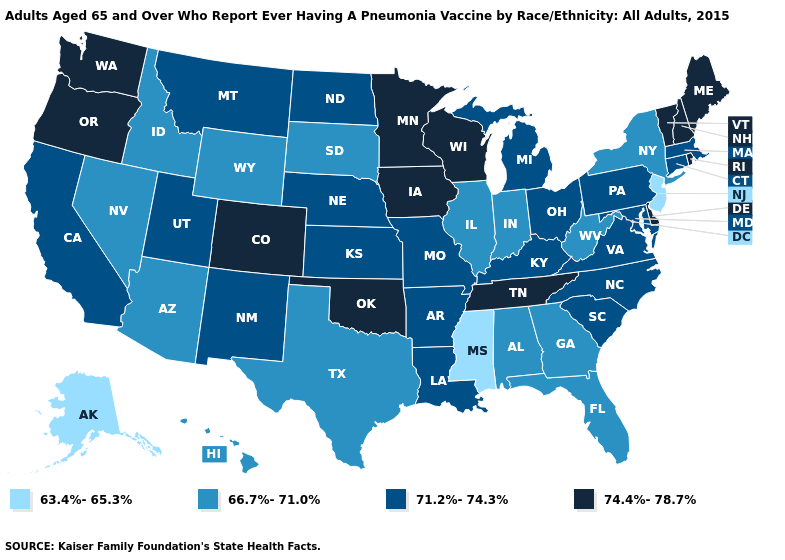Name the states that have a value in the range 63.4%-65.3%?
Keep it brief. Alaska, Mississippi, New Jersey. What is the lowest value in states that border Kentucky?
Answer briefly. 66.7%-71.0%. Name the states that have a value in the range 66.7%-71.0%?
Write a very short answer. Alabama, Arizona, Florida, Georgia, Hawaii, Idaho, Illinois, Indiana, Nevada, New York, South Dakota, Texas, West Virginia, Wyoming. Does Colorado have the same value as Washington?
Keep it brief. Yes. Name the states that have a value in the range 63.4%-65.3%?
Short answer required. Alaska, Mississippi, New Jersey. What is the value of Hawaii?
Give a very brief answer. 66.7%-71.0%. Does the first symbol in the legend represent the smallest category?
Answer briefly. Yes. Name the states that have a value in the range 66.7%-71.0%?
Write a very short answer. Alabama, Arizona, Florida, Georgia, Hawaii, Idaho, Illinois, Indiana, Nevada, New York, South Dakota, Texas, West Virginia, Wyoming. Which states have the highest value in the USA?
Be succinct. Colorado, Delaware, Iowa, Maine, Minnesota, New Hampshire, Oklahoma, Oregon, Rhode Island, Tennessee, Vermont, Washington, Wisconsin. What is the value of Missouri?
Give a very brief answer. 71.2%-74.3%. Does Mississippi have the lowest value in the South?
Keep it brief. Yes. Is the legend a continuous bar?
Short answer required. No. Among the states that border North Dakota , does South Dakota have the lowest value?
Write a very short answer. Yes. What is the highest value in states that border Georgia?
Keep it brief. 74.4%-78.7%. What is the value of Pennsylvania?
Give a very brief answer. 71.2%-74.3%. 